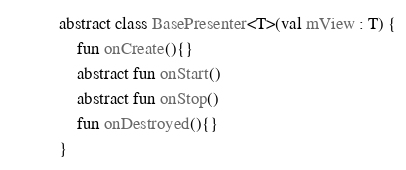<code> <loc_0><loc_0><loc_500><loc_500><_Kotlin_>abstract class BasePresenter<T>(val mView : T) {
    fun onCreate(){}
    abstract fun onStart()
    abstract fun onStop()
    fun onDestroyed(){}
}</code> 